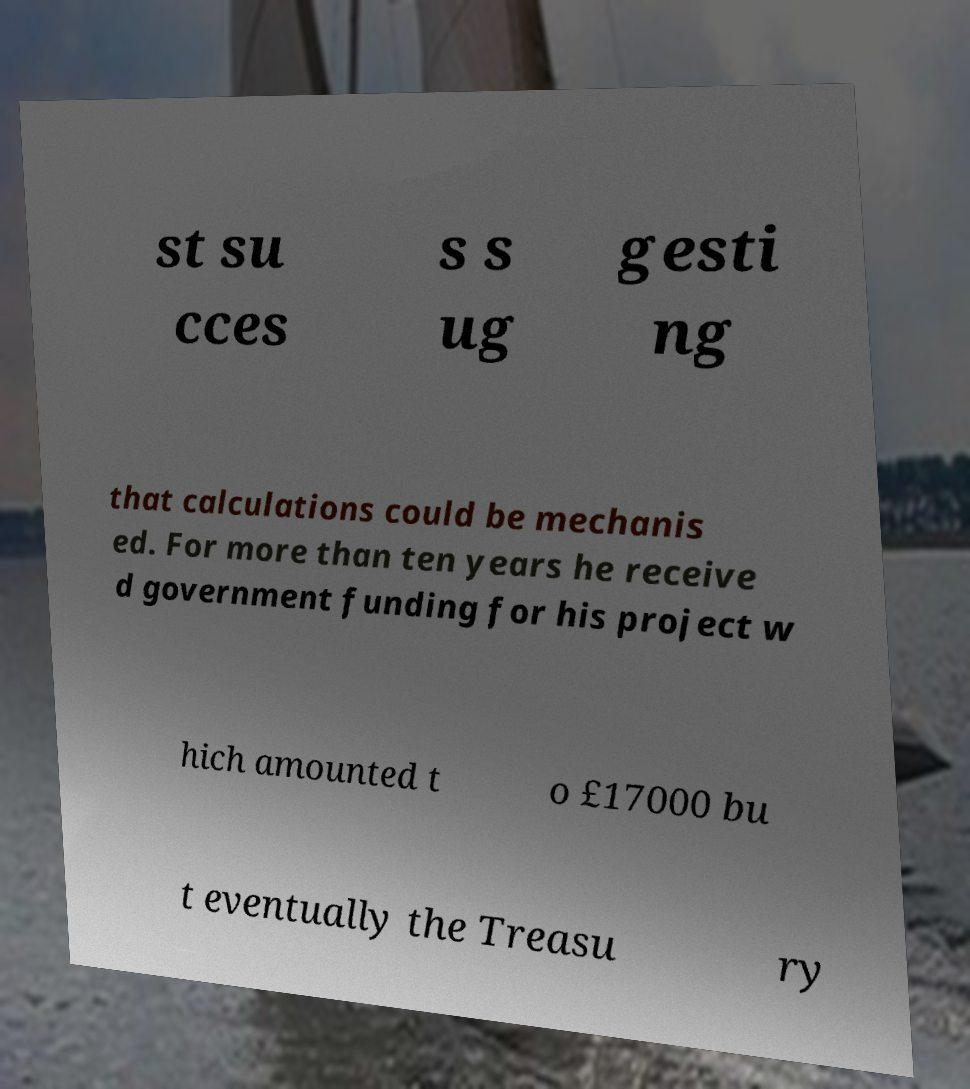I need the written content from this picture converted into text. Can you do that? st su cces s s ug gesti ng that calculations could be mechanis ed. For more than ten years he receive d government funding for his project w hich amounted t o £17000 bu t eventually the Treasu ry 